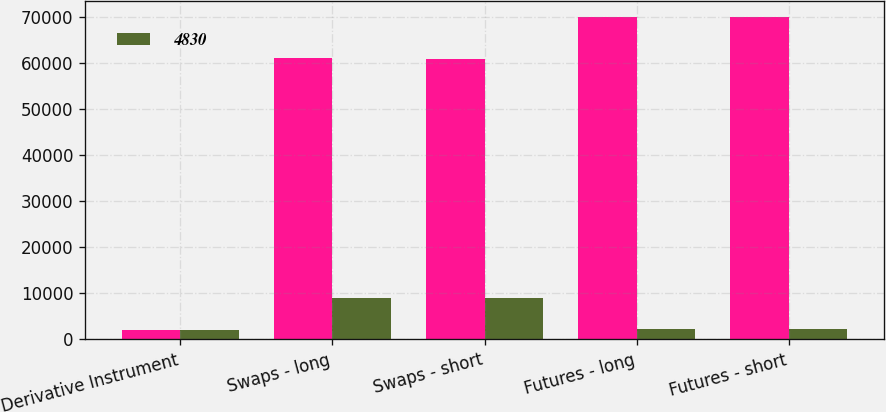Convert chart. <chart><loc_0><loc_0><loc_500><loc_500><stacked_bar_chart><ecel><fcel>Derivative Instrument<fcel>Swaps - long<fcel>Swaps - short<fcel>Futures - long<fcel>Futures - short<nl><fcel>nan<fcel>2013<fcel>61002<fcel>60819<fcel>69939<fcel>69923<nl><fcel>4830<fcel>2014<fcel>9000<fcel>9000<fcel>2236<fcel>2236<nl></chart> 